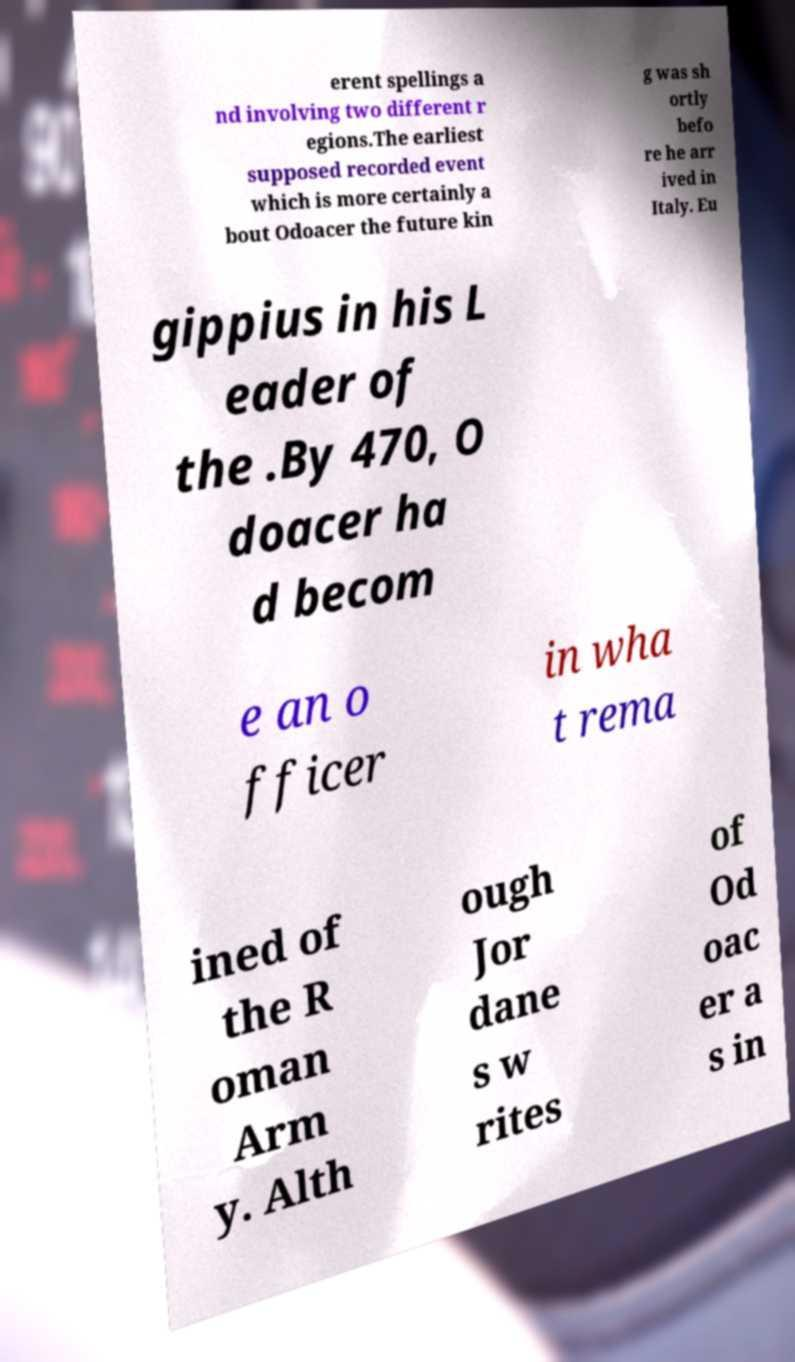Can you accurately transcribe the text from the provided image for me? erent spellings a nd involving two different r egions.The earliest supposed recorded event which is more certainly a bout Odoacer the future kin g was sh ortly befo re he arr ived in Italy. Eu gippius in his L eader of the .By 470, O doacer ha d becom e an o fficer in wha t rema ined of the R oman Arm y. Alth ough Jor dane s w rites of Od oac er a s in 